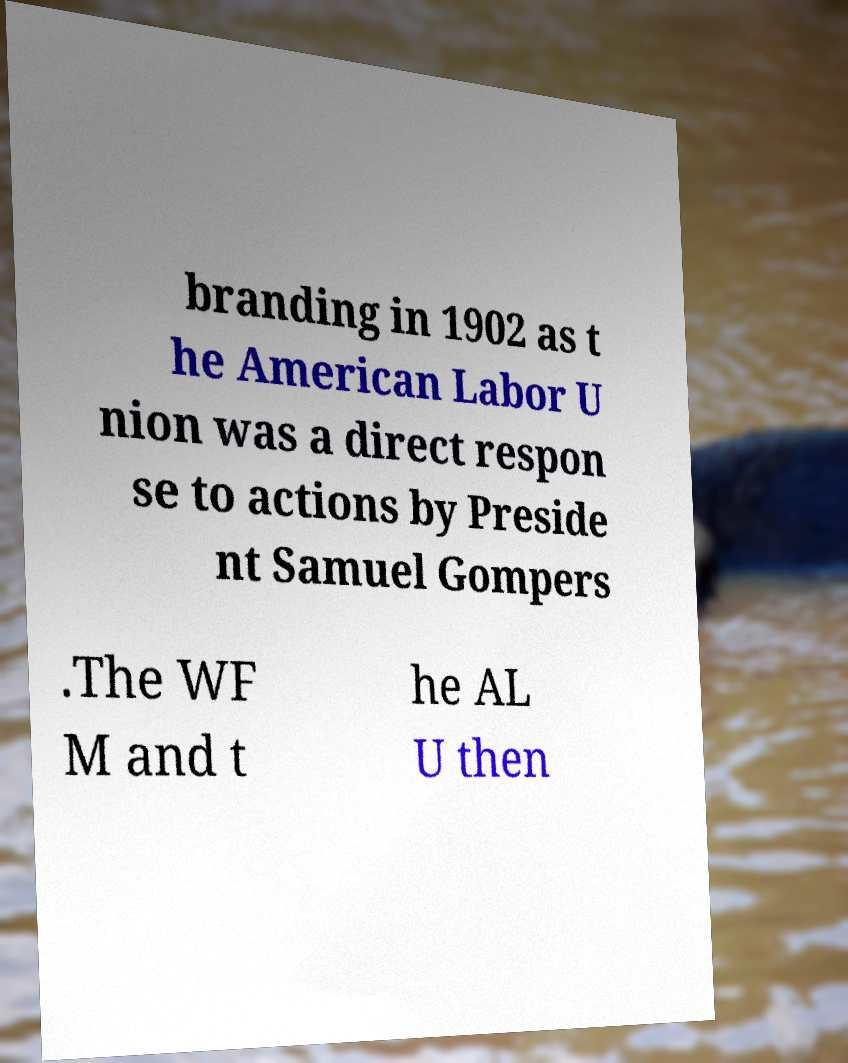Could you extract and type out the text from this image? branding in 1902 as t he American Labor U nion was a direct respon se to actions by Preside nt Samuel Gompers .The WF M and t he AL U then 